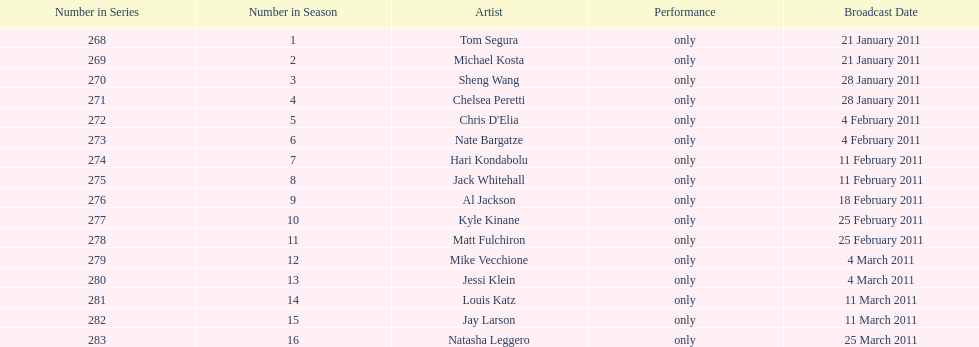How many episodes only had one performer? 16. 